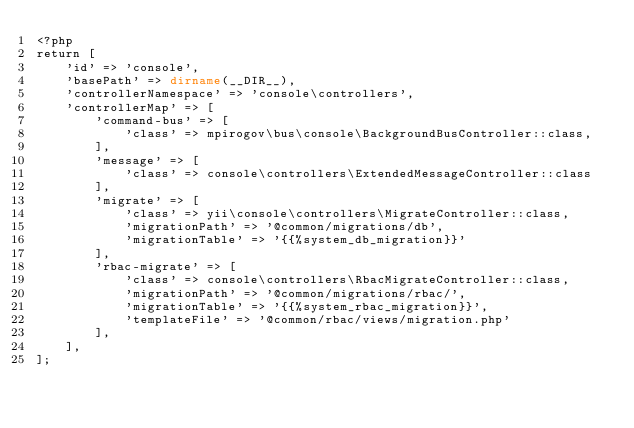Convert code to text. <code><loc_0><loc_0><loc_500><loc_500><_PHP_><?php
return [
    'id' => 'console',
    'basePath' => dirname(__DIR__),
    'controllerNamespace' => 'console\controllers',
    'controllerMap' => [
        'command-bus' => [
            'class' => mpirogov\bus\console\BackgroundBusController::class,
        ],
        'message' => [
            'class' => console\controllers\ExtendedMessageController::class
        ],
        'migrate' => [
            'class' => yii\console\controllers\MigrateController::class,
            'migrationPath' => '@common/migrations/db',
            'migrationTable' => '{{%system_db_migration}}'
        ],
        'rbac-migrate' => [
            'class' => console\controllers\RbacMigrateController::class,
            'migrationPath' => '@common/migrations/rbac/',
            'migrationTable' => '{{%system_rbac_migration}}',
            'templateFile' => '@common/rbac/views/migration.php'
        ],
    ],
];
</code> 